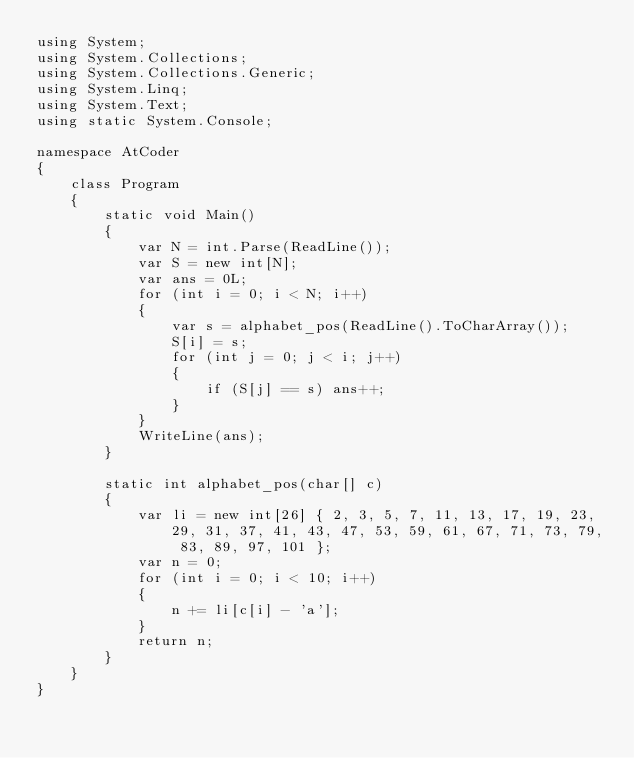<code> <loc_0><loc_0><loc_500><loc_500><_C#_>using System;
using System.Collections;
using System.Collections.Generic;
using System.Linq;
using System.Text;
using static System.Console;

namespace AtCoder
{
    class Program
    {
        static void Main()
        {
            var N = int.Parse(ReadLine());
            var S = new int[N];
            var ans = 0L;
            for (int i = 0; i < N; i++)
            {
                var s = alphabet_pos(ReadLine().ToCharArray());
                S[i] = s;
                for (int j = 0; j < i; j++)
                {
                    if (S[j] == s) ans++;
                }
            }
            WriteLine(ans);
        }

        static int alphabet_pos(char[] c)
        {
            var li = new int[26] { 2, 3, 5, 7, 11, 13, 17, 19, 23, 29, 31, 37, 41, 43, 47, 53, 59, 61, 67, 71, 73, 79, 83, 89, 97, 101 };
            var n = 0;
            for (int i = 0; i < 10; i++)
            {
                n += li[c[i] - 'a'];
            }
            return n;
        }
    }
}
</code> 